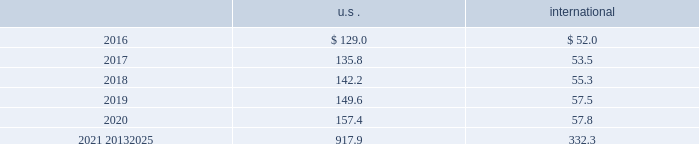Mutual and pooled funds shares of mutual funds are valued at the net asset value ( nav ) quoted on the exchange where the fund is traded and are classified as level 1 assets .
Units of pooled funds are valued at the per unit nav determined by the fund manager and are classified as level 2 assets .
The investments are utilizing nav as a practical expedient for fair value .
Corporate and government bonds corporate and government bonds are classified as level 2 assets , as they are either valued at quoted market prices from observable pricing sources at the reporting date or valued based upon comparable securities with similar yields and credit ratings .
Mortgage and asset-backed securities mortgage and asset 2013backed securities are classified as level 2 assets , as they are either valued at quoted market prices from observable pricing sources at the reporting date or valued based upon comparable securities with similar yields , credit ratings , and purpose of the underlying loan .
Real estate pooled funds real estate pooled funds are classified as level 3 assets , as they are carried at the estimated fair value of the underlying properties .
Estimated fair value is calculated utilizing a combination of key inputs , such as revenue and expense growth rates , terminal capitalization rates , and discount rates .
These key inputs are consistent with practices prevailing within the real estate investment management industry .
Other pooled funds other pooled funds classified as level 2 assets are valued at the nav of the shares held at year end , which is based on the fair value of the underlying investments .
Securities and interests classified as level 3 are carried at the estimated fair value of the underlying investments .
The underlying investments are valued based on bids from brokers or other third-party vendor sources that utilize expected cash flow streams and other uncorroborated data , including counterparty credit quality , default risk , discount rates , and the overall capital market liquidity .
Insurance contracts insurance contracts are classified as level 3 assets , as they are carried at contract value , which approximates the estimated fair value .
The estimated fair value is based on the fair value of the underlying investment of the insurance company .
Contributions and projected benefit payments pension contributions to funded plans and benefit payments for unfunded plans for fiscal year 2015 were $ 137.5 .
Contributions resulted primarily from an assessment of long-term funding requirements of the plans and tax planning .
Benefit payments to unfunded plans were due primarily to the timing of retirements and cost reduction actions .
We anticipate contributing $ 100 to $ 120 to the defined benefit pension plans in 2016 .
These contributions are driven primarily by benefit payments for unfunded plans , which are dependent upon timing of retirements and actions to reorganize the business .
Projected benefit payments , which reflect expected future service , are as follows: .
These estimated benefit payments are based on assumptions about future events .
Actual benefit payments may vary significantly from these estimates. .
Considering the years 2021-2025 , what is the difference between the average projected benefit payments for the u.s . and international? 
Rationale: it is the difference between the division of the accumulated value for the 2021-2025 period in the u.s . and international by 5 ( number of years ) .
Computations: ((917.9 / 5) - (332.3 / 5))
Answer: 117.12. 